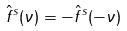Convert formula to latex. <formula><loc_0><loc_0><loc_500><loc_500>\hat { f } ^ { s } ( \nu ) = - \hat { f } ^ { s } ( - \nu )</formula> 